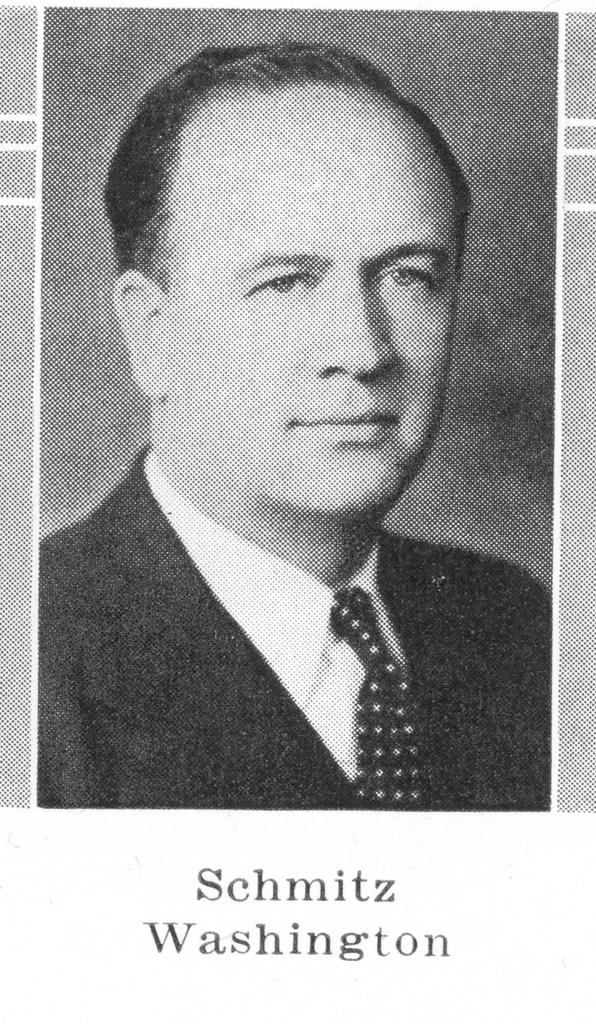Who is the person featured in the image? The person featured in the image is Schwitz Washington. What type of bun is being served at the amusement park mentioned in the news article in the image? There is no amusement park or news article mentioned in the image, and therefore no bun being served can be observed. 